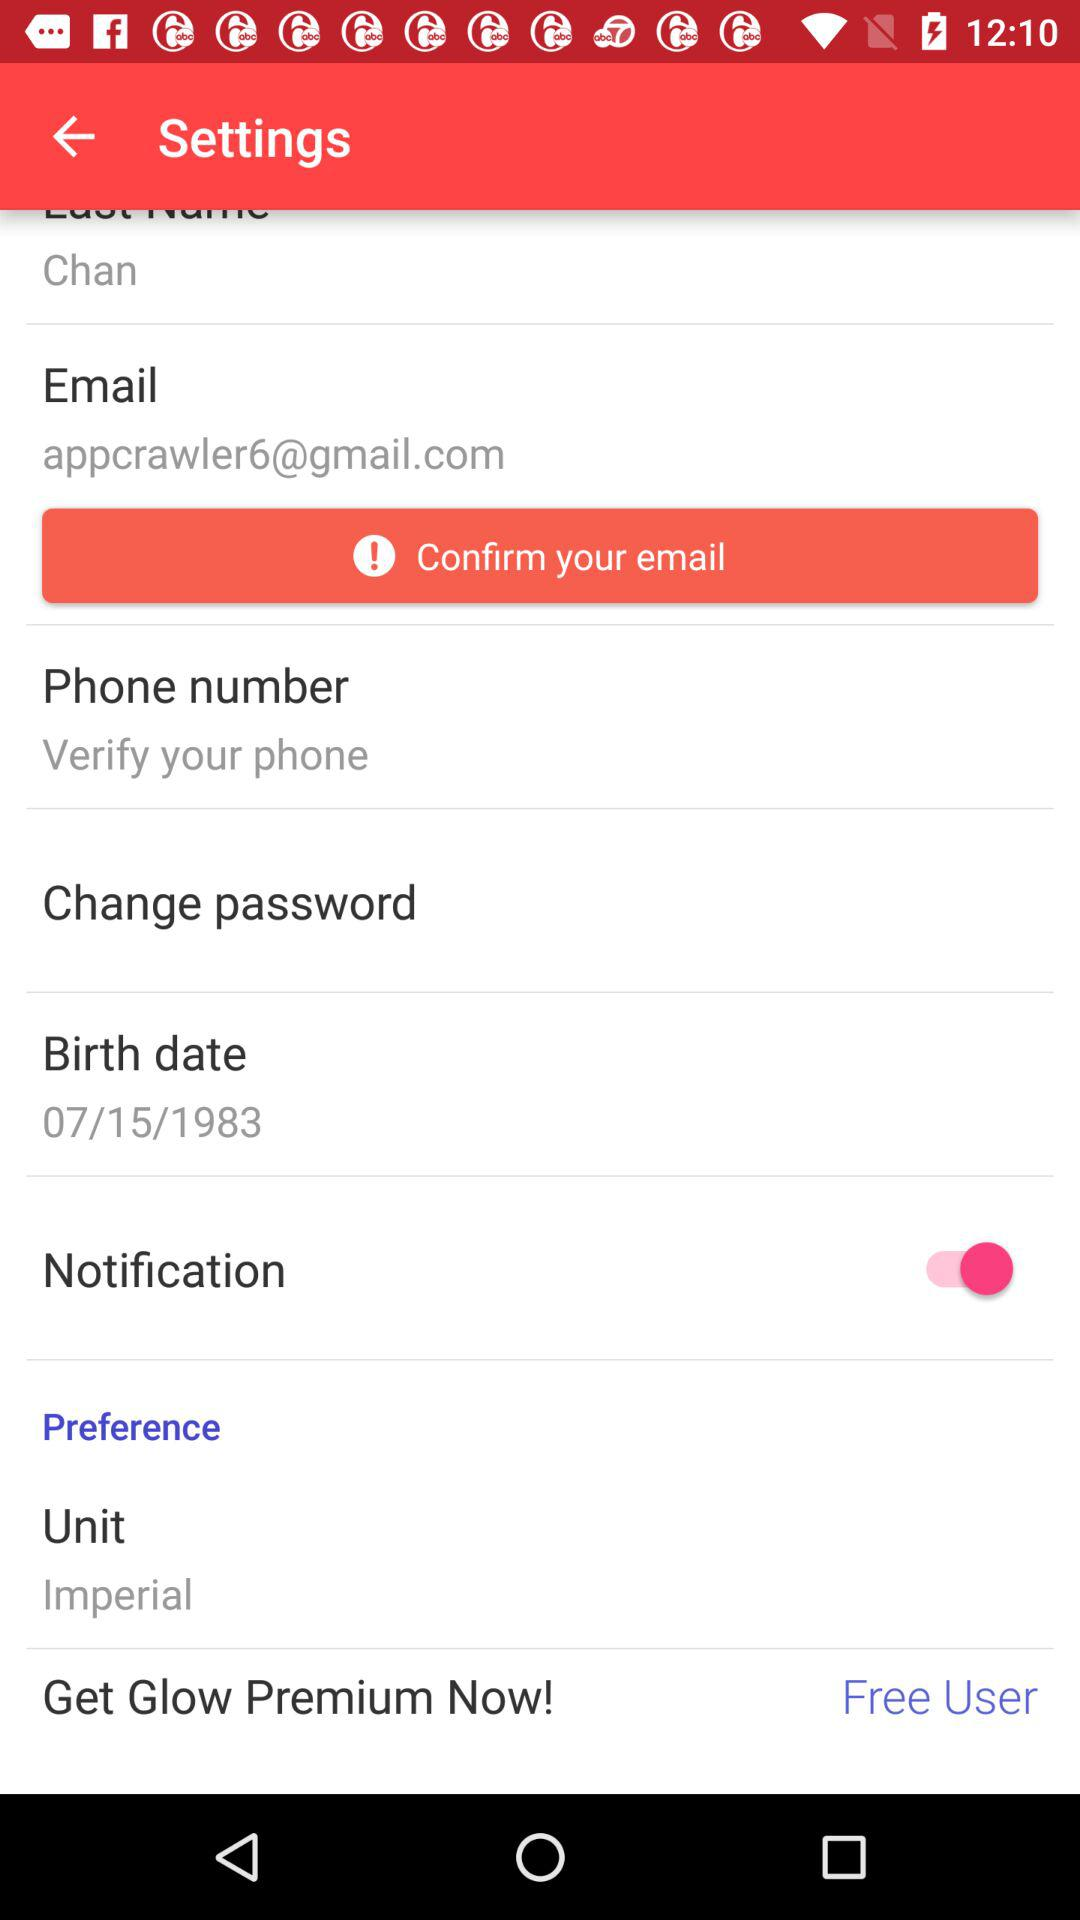What is the email address? The email address is appcrawler6@gmail.com. 